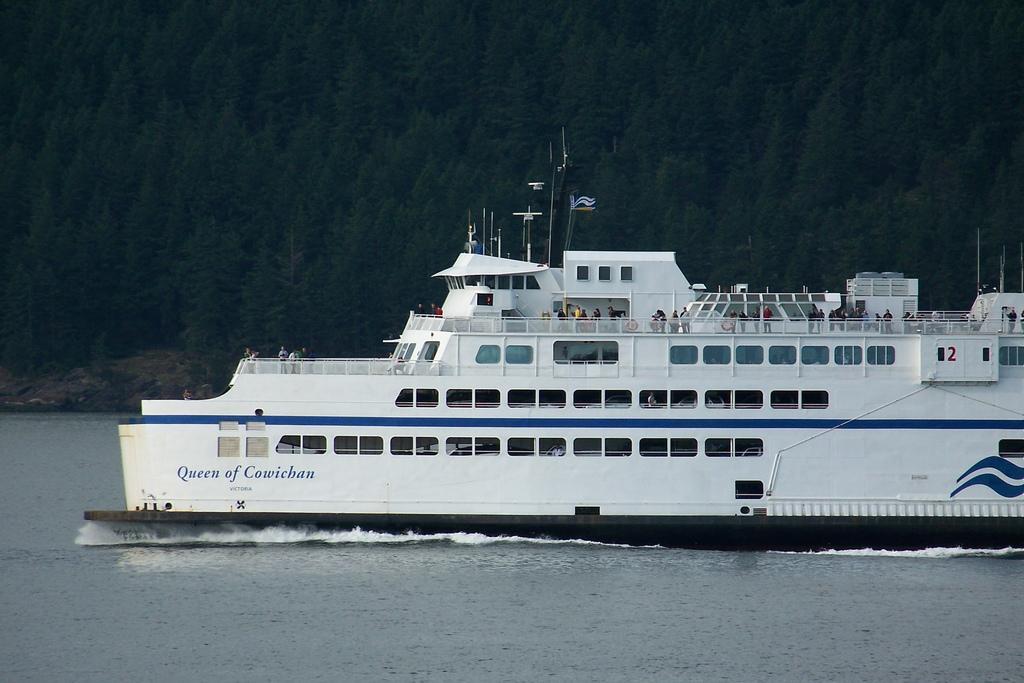How would you summarize this image in a sentence or two? There is a white color ship on the surface of water as we can see at the bottom of this image, and there are some trees in the background. 